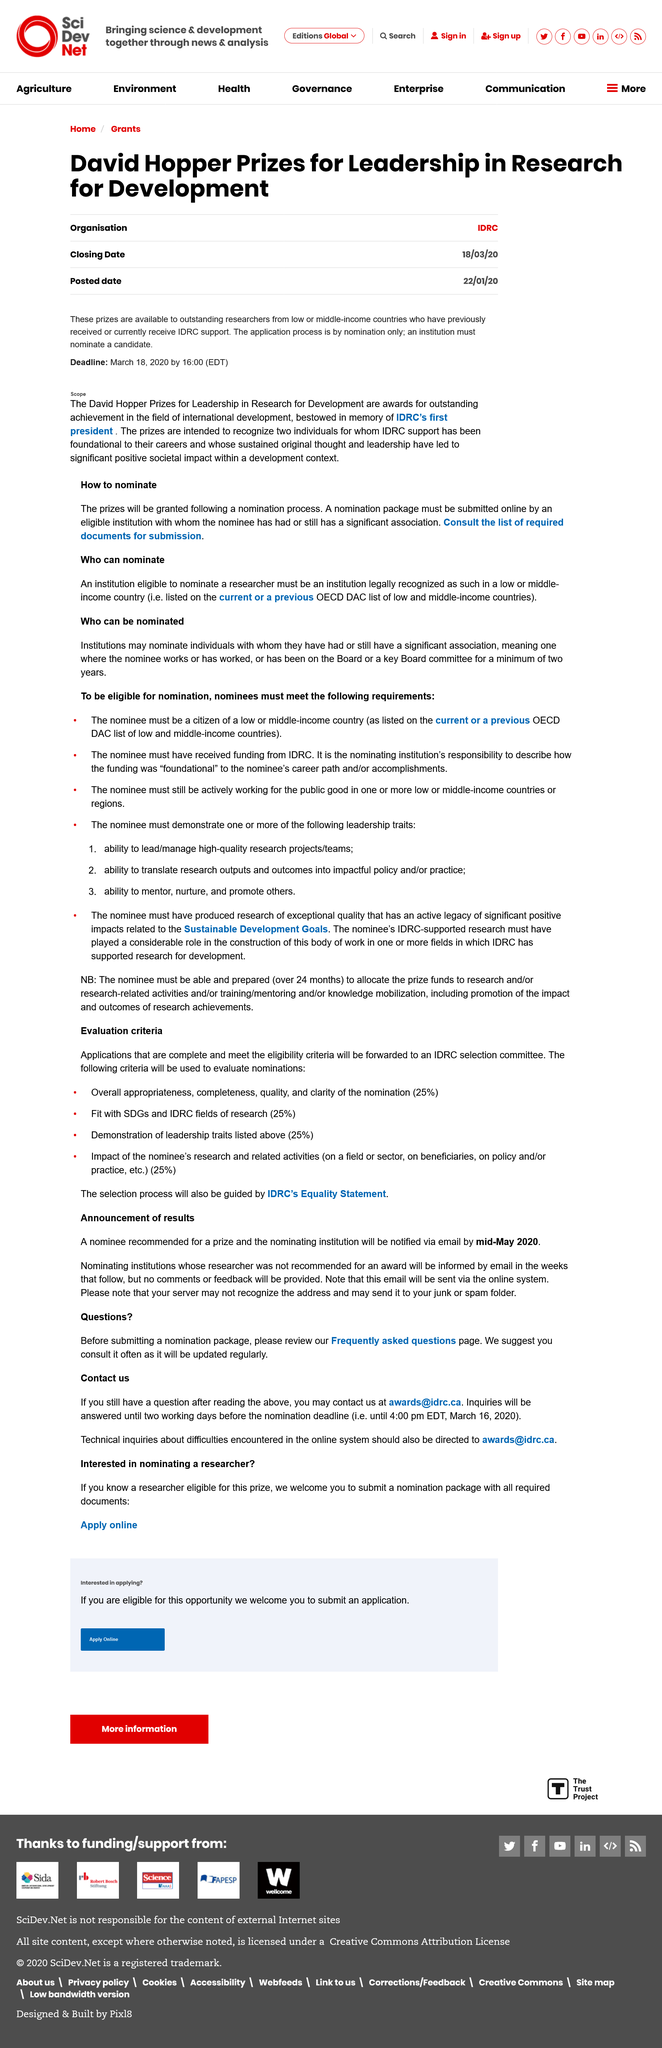Point out several critical features in this image. The David Hopper Prizes are awarded to recognize and honor exceptional leadership in research for development. The deadline for applications is March 18, 2020. The prizes are available to outstanding researchers from low or middle-income countries who have previously received support from the International Development Research Centre (IDRC). 